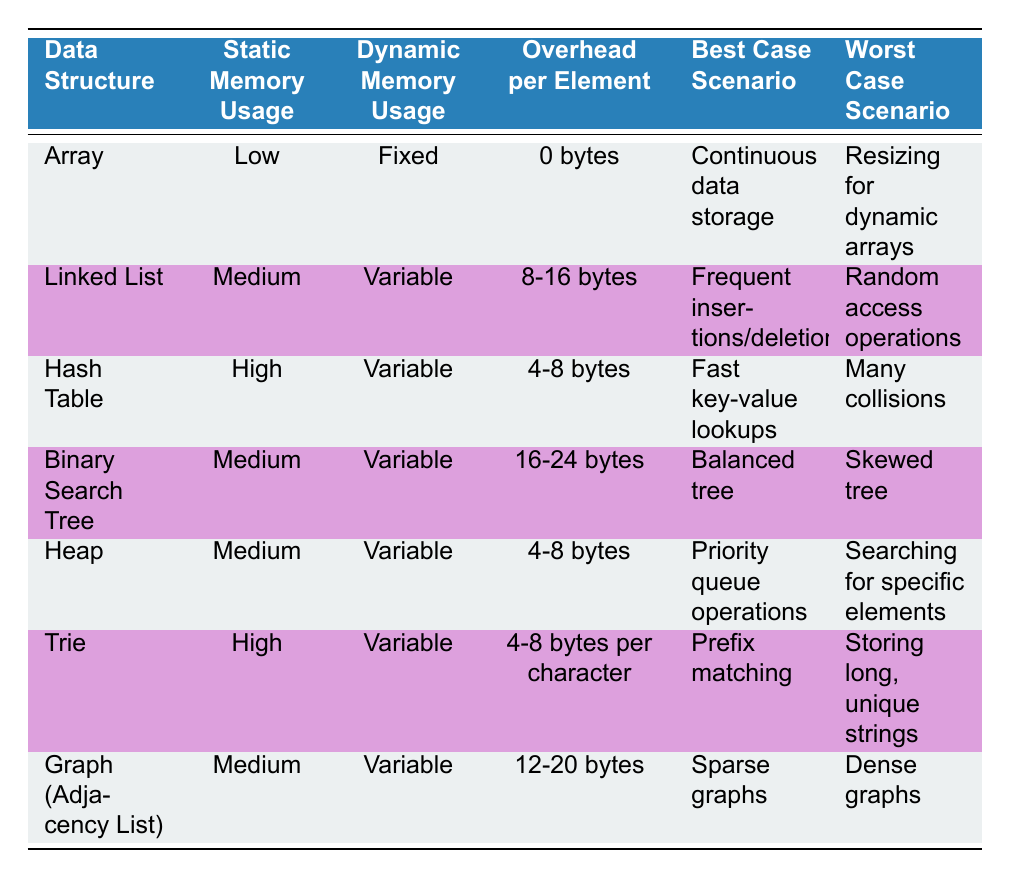What is the overhead per element for a Linked List? Looking at the Linked List row in the table, we can directly see that the overhead per element is listed as "8-16 bytes."
Answer: 8-16 bytes Which data structure has the highest static memory usage? Reviewing the static memory usage column, we find that both the Hash Table and Trie are classified as having "High" memory usage, which is the highest classification in this table.
Answer: Hash Table, Trie What is the average overhead per element for the data structures with "Medium" static memory usage? We identify the data structures with "Medium" static memory usage, which are Linked List, Binary Search Tree, Heap, and Graph (Adjacency List). The overheads are 8-16 bytes, 16-24 bytes, 4-8 bytes, and 12-20 bytes respectively. Calculating an average would be complex due to the ranges, but we can take midpoints: (12 + 20 + 6 + 16) / 4 = 13.5 bytes (for an approximate average). So, the average overhead per element is approximately 13.5 bytes.
Answer: Approximately 13.5 bytes Does the Graph (Adjacency List) have a fixed dynamic memory usage? The Graph (Adjacency List) is categorized under "Variable" dynamic memory usage, as seen in the respective column of the table. Therefore, the answer is "No."
Answer: No In which memory usage scenario does a Hash Table perform best? By examining the best case scenario for Hash Table, it is "Fast key-value lookups," as noted in the corresponding row of the table.
Answer: Fast key-value lookups Which data structure has the highest overhead per element and in what situation does it excel? The Trie has the highest overhead per element at "4-8 bytes per character," and it excels in the best case scenario of "Prefix matching," according to the table.
Answer: Trie, Prefix matching What are the worst-case scenarios for data structures with high static memory usage? The data structures with high static memory usage are Hash Table and Trie. The worst-case scenario for the Hash Table is "Many collisions," and for the Trie, it is "Storing long, unique strings."
Answer: Many collisions, Storing long, unique strings Are all data structures listed in the table compatible with priority queue operations? Examining the types of data structures listed, only the Heap is categorized under "Priority queue operations." The rest do not indicate compatibility with priority queues. Therefore, the answer is "No."
Answer: No 